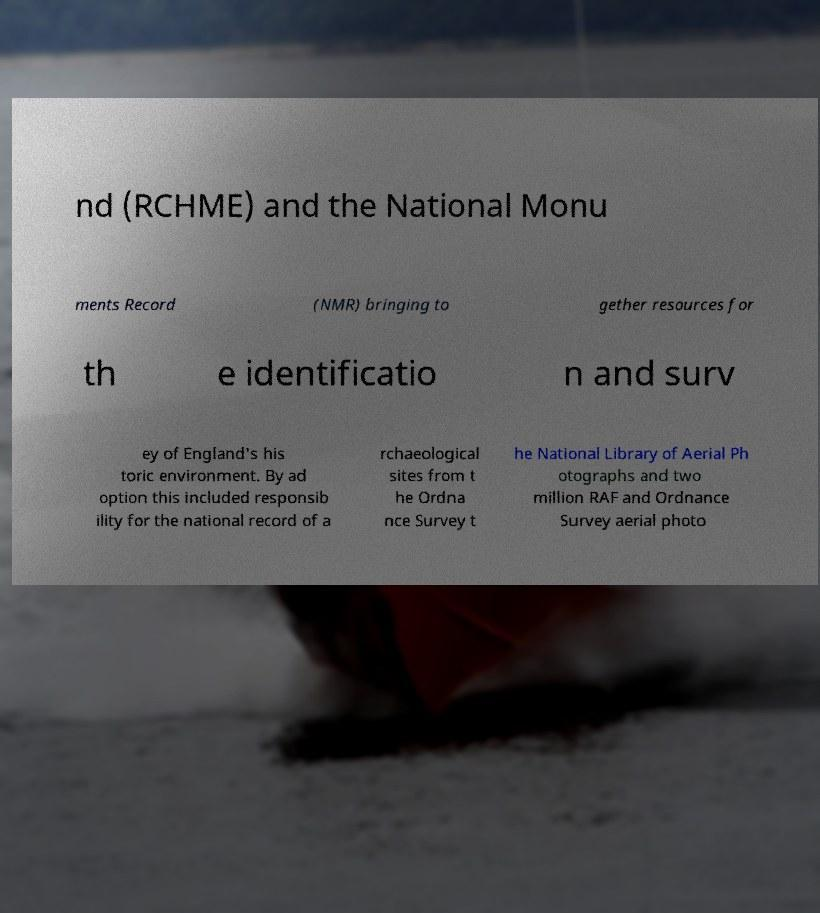There's text embedded in this image that I need extracted. Can you transcribe it verbatim? nd (RCHME) and the National Monu ments Record (NMR) bringing to gether resources for th e identificatio n and surv ey of England's his toric environment. By ad option this included responsib ility for the national record of a rchaeological sites from t he Ordna nce Survey t he National Library of Aerial Ph otographs and two million RAF and Ordnance Survey aerial photo 